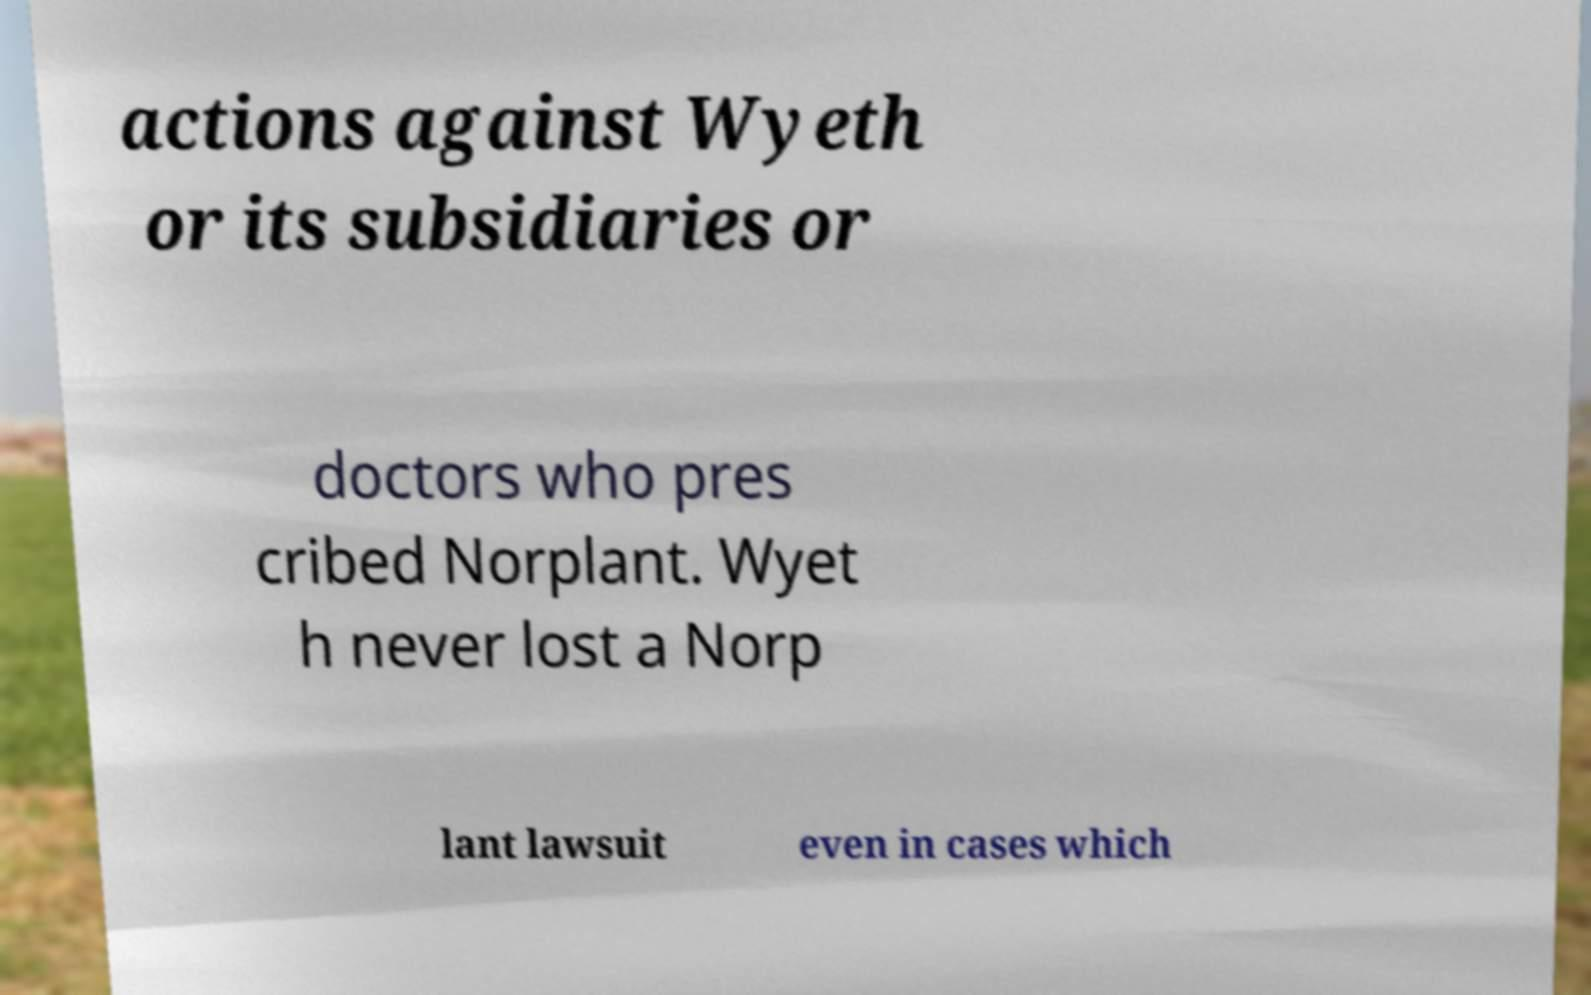For documentation purposes, I need the text within this image transcribed. Could you provide that? actions against Wyeth or its subsidiaries or doctors who pres cribed Norplant. Wyet h never lost a Norp lant lawsuit even in cases which 